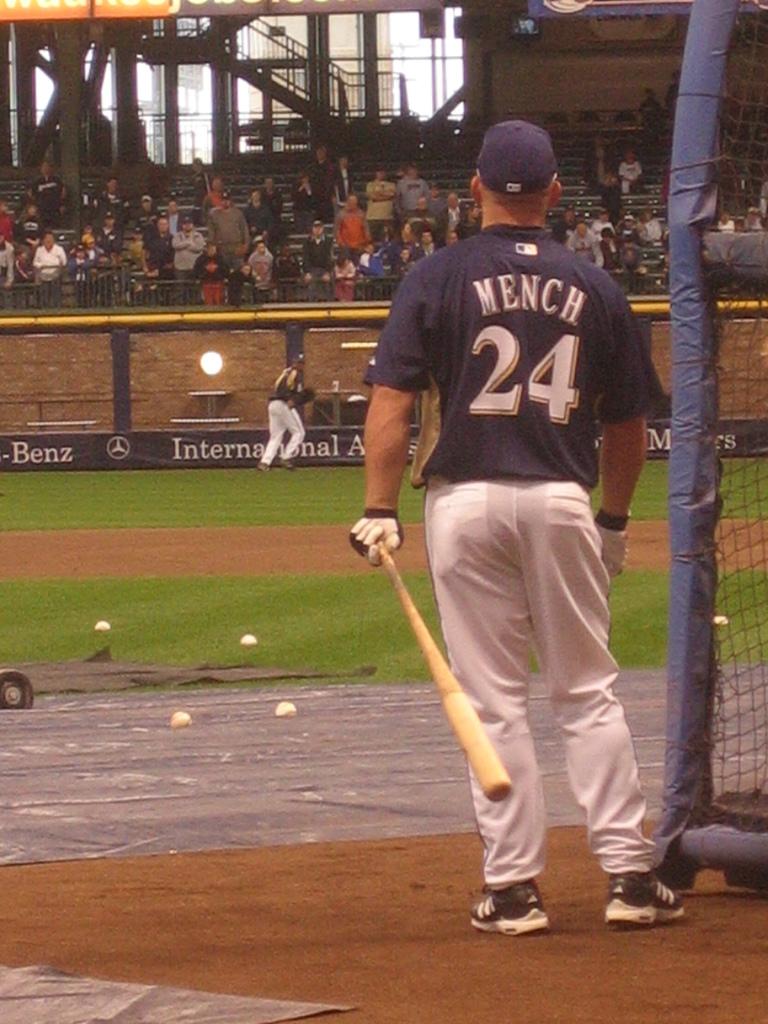What number does mench wear?
Give a very brief answer. 24. Which car company is advertising on the banner?
Provide a succinct answer. Mercedes-benz. 